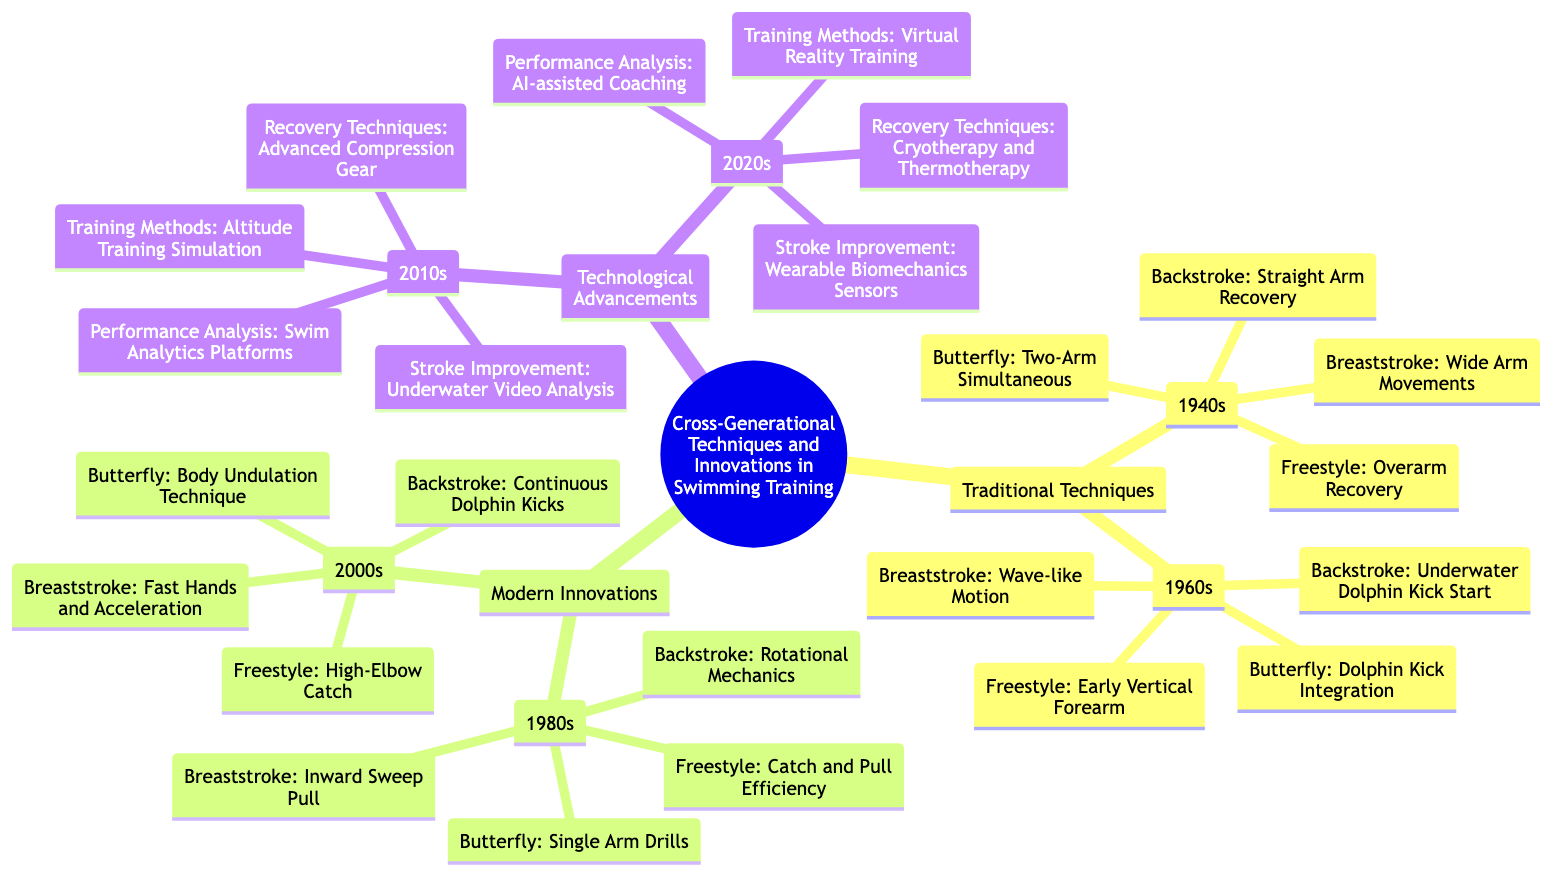What are the two main categories in the family tree? The diagram clearly presents three primary categories: Traditional Techniques, Modern Innovations, and Technological Advancements. These are the main branches of the tree that represent different eras and approaches in swimming training.
Answer: Traditional Techniques, Modern Innovations, Technological Advancements In which decade was the concept of "High-Elbow Catch" introduced? The High-Elbow Catch is listed under the 2000s in the Modern Innovations section. By locating the "Freestyle" entry in that decade, we can ascertain the introduction of this technique.
Answer: 2000s How many specific techniques are associated with the 1960s? Under the 1960s branch in Traditional Techniques, there are four specific techniques listed: one for each stroke (Freestyle, Butterfly, Breaststroke, Backstroke), making a total of four techniques for that decade.
Answer: 4 What is the stroke improvement technique revealed in the 2010s? The 2010s section under Technological Advancements includes "Underwater Video Analysis" as a stroke improvement technique. Finding this entry involves checking the relevant category (Technological Advancements) and the specific decade (2010s).
Answer: Underwater Video Analysis Which decade introduced the "Dolphin Kick Integration" technique? The "Dolphin Kick Integration" technique is found under the Butterfly stroke in the 1960s category. Thus, the 1960s can be identified as when this technique was introduced by examining the respective year and stroke.
Answer: 1960s What recovery technique was presented in the 2020s? In the 2020s section of the Technological Advancements category, the recovery technique listed is "Cryotherapy and Thermotherapy." This can be confirmed by looking at the entry within that specific decade.
Answer: Cryotherapy and Thermotherapy Which category includes "AI-assisted Coaching"? The "AI-assisted Coaching" concept is found under the 2020s in the Technological Advancements section of the diagram, indicating it belongs to the modern technological approaches in swimming training.
Answer: Technological Advancements How many swimming strokes are mentioned in the 1980s innovations? The 1980s category lists four strokes: Freestyle, Butterfly, Breaststroke, and Backstroke. Arriving at the answer involves counting the distinct stroke entries within that decade.
Answer: 4 What is the main training method innovation introduced in the 2010s? The primary training method revealed in the 2010s is "Altitude Training Simulation," which can be determined by reviewing the Training Methods entry in that decade.
Answer: Altitude Training Simulation 